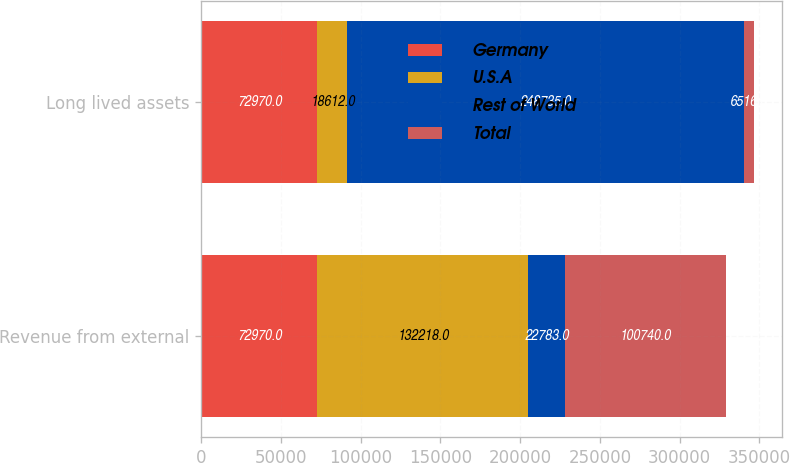Convert chart. <chart><loc_0><loc_0><loc_500><loc_500><stacked_bar_chart><ecel><fcel>Revenue from external<fcel>Long lived assets<nl><fcel>Germany<fcel>72970<fcel>72970<nl><fcel>U.S.A<fcel>132218<fcel>18612<nl><fcel>Rest of World<fcel>22783<fcel>248735<nl><fcel>Total<fcel>100740<fcel>6516<nl></chart> 